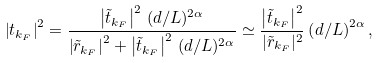Convert formula to latex. <formula><loc_0><loc_0><loc_500><loc_500>\left | { t } _ { k _ { F } } \right | ^ { 2 } = \frac { \left | \tilde { t } _ { k _ { F } } \right | ^ { 2 } \, ( d / L ) ^ { 2 \alpha } } { { \left | \tilde { r } _ { k _ { F } } \right | ^ { 2 } + \left | \tilde { t } _ { k _ { F } } \right | ^ { 2 } \, ( d / L ) ^ { 2 \alpha } } } \simeq \frac { \left | \tilde { t } _ { k _ { F } } \right | ^ { 2 } } { | \tilde { r } _ { k _ { F } } | ^ { 2 } } \left ( d / L \right ) ^ { 2 \alpha } ,</formula> 